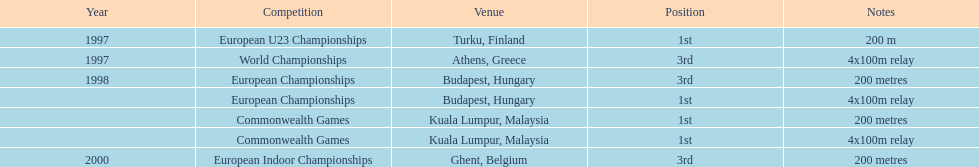In what year did england reach the pinnacle of success in the 200-meter race? 1997. 